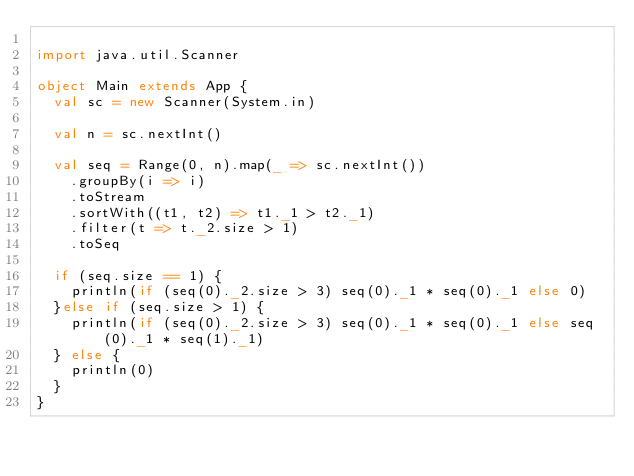Convert code to text. <code><loc_0><loc_0><loc_500><loc_500><_Scala_>
import java.util.Scanner

object Main extends App {
  val sc = new Scanner(System.in)

  val n = sc.nextInt()

  val seq = Range(0, n).map(_ => sc.nextInt())
    .groupBy(i => i)
    .toStream
    .sortWith((t1, t2) => t1._1 > t2._1)
    .filter(t => t._2.size > 1)
    .toSeq

  if (seq.size == 1) {
    println(if (seq(0)._2.size > 3) seq(0)._1 * seq(0)._1 else 0)
  }else if (seq.size > 1) {
    println(if (seq(0)._2.size > 3) seq(0)._1 * seq(0)._1 else seq(0)._1 * seq(1)._1)
  } else {
    println(0)
  }
}
</code> 